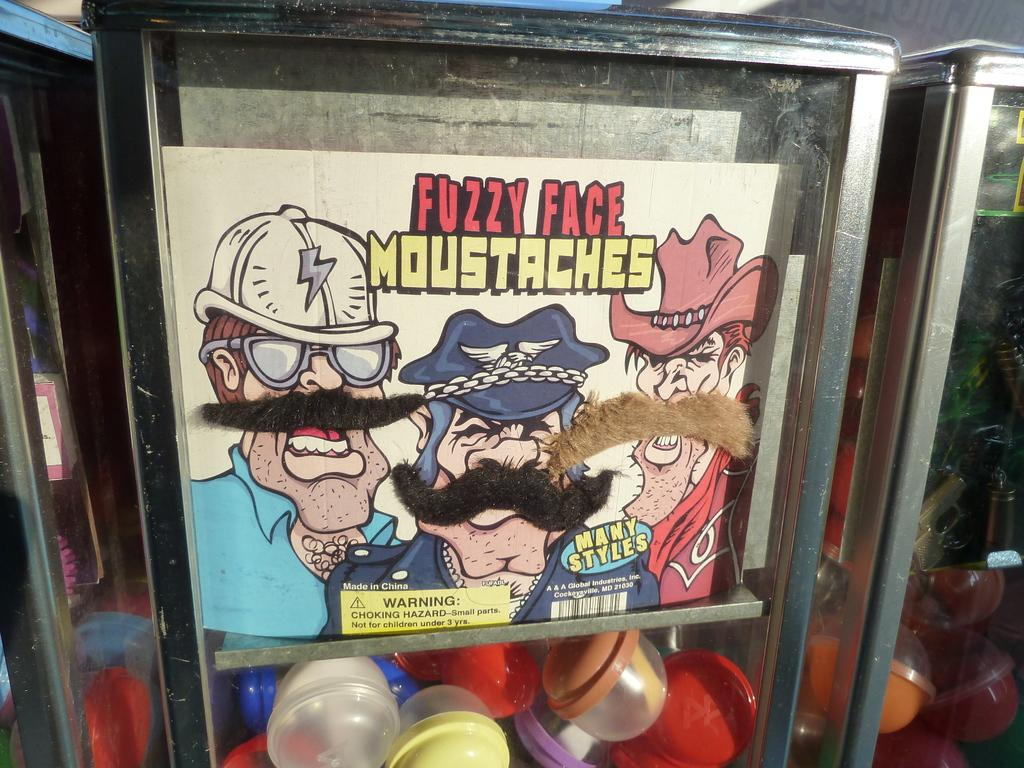What objects are present in the image that can hold items? There are containers in the image that can hold items. What is placed inside the containers? There are bowls placed in the containers. What other object can be seen in the image? There is a board in the image. What type of operation is being performed on the board in the image? There is no operation being performed on the board in the image; it is simply a stationary object. 